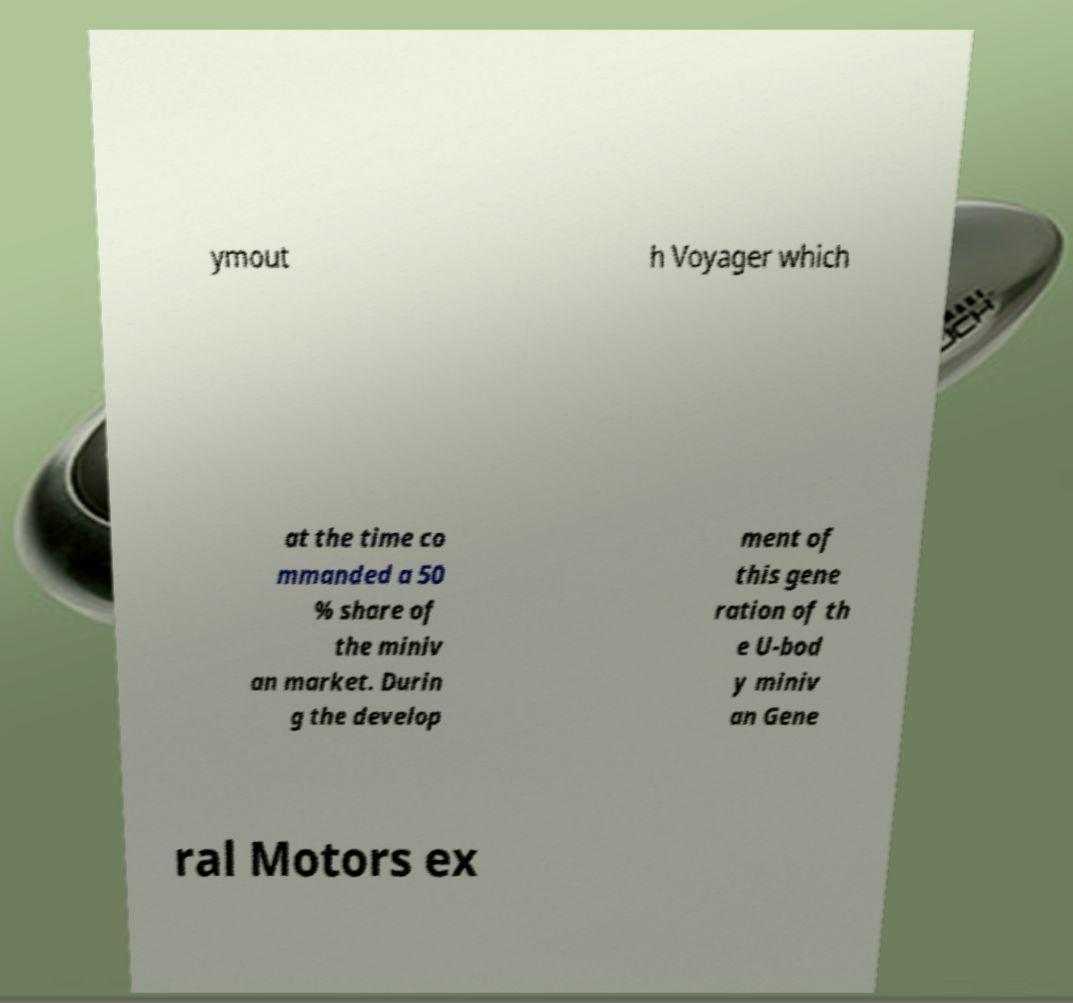Please identify and transcribe the text found in this image. ymout h Voyager which at the time co mmanded a 50 % share of the miniv an market. Durin g the develop ment of this gene ration of th e U-bod y miniv an Gene ral Motors ex 